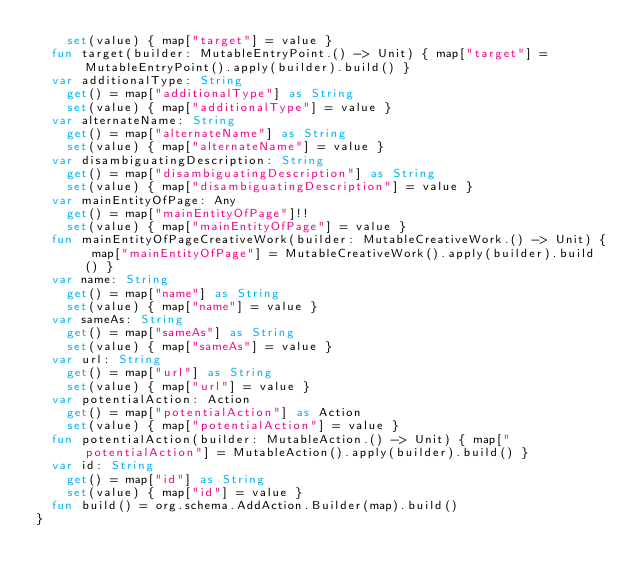Convert code to text. <code><loc_0><loc_0><loc_500><loc_500><_Kotlin_>    set(value) { map["target"] = value }
  fun target(builder: MutableEntryPoint.() -> Unit) { map["target"] = MutableEntryPoint().apply(builder).build() }
  var additionalType: String
    get() = map["additionalType"] as String
    set(value) { map["additionalType"] = value }
  var alternateName: String
    get() = map["alternateName"] as String
    set(value) { map["alternateName"] = value }
  var disambiguatingDescription: String
    get() = map["disambiguatingDescription"] as String
    set(value) { map["disambiguatingDescription"] = value }
  var mainEntityOfPage: Any
    get() = map["mainEntityOfPage"]!!
    set(value) { map["mainEntityOfPage"] = value }
  fun mainEntityOfPageCreativeWork(builder: MutableCreativeWork.() -> Unit) { map["mainEntityOfPage"] = MutableCreativeWork().apply(builder).build() }
  var name: String
    get() = map["name"] as String
    set(value) { map["name"] = value }
  var sameAs: String
    get() = map["sameAs"] as String
    set(value) { map["sameAs"] = value }
  var url: String
    get() = map["url"] as String
    set(value) { map["url"] = value }
  var potentialAction: Action
    get() = map["potentialAction"] as Action
    set(value) { map["potentialAction"] = value }
  fun potentialAction(builder: MutableAction.() -> Unit) { map["potentialAction"] = MutableAction().apply(builder).build() }
  var id: String
    get() = map["id"] as String
    set(value) { map["id"] = value }
  fun build() = org.schema.AddAction.Builder(map).build()
}
</code> 